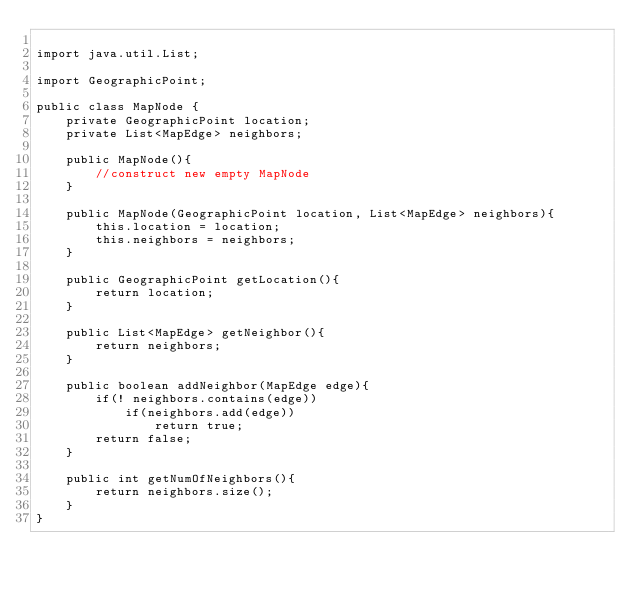<code> <loc_0><loc_0><loc_500><loc_500><_Java_>
import java.util.List;

import GeographicPoint;

public class MapNode {
	private GeographicPoint location;
	private List<MapEdge> neighbors;
	
	public MapNode(){
		//construct new empty MapNode
	}
	
	public MapNode(GeographicPoint location, List<MapEdge> neighbors){
		this.location = location;
		this.neighbors = neighbors;
	}
	
	public GeographicPoint getLocation(){
		return location;
	}
	
	public List<MapEdge> getNeighbor(){
		return neighbors;
	}
	
	public boolean addNeighbor(MapEdge edge){
		if(! neighbors.contains(edge))
			if(neighbors.add(edge))
				return true;
		return false;
	}
	
	public int getNumOfNeighbors(){
		return neighbors.size();
	}
}
</code> 